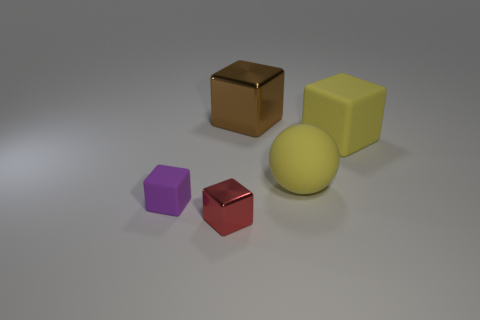What might be the purpose of arranging these objects this way? This arrangement might be intended for visual or educational purposes. Visually, the varying shapes and colors create an interesting composition that demonstrates contrast and diversity. Educationally, it could be used to teach about geometry, color theory, or material properties such as reflectiveness and texture in a simple, clear manner. 